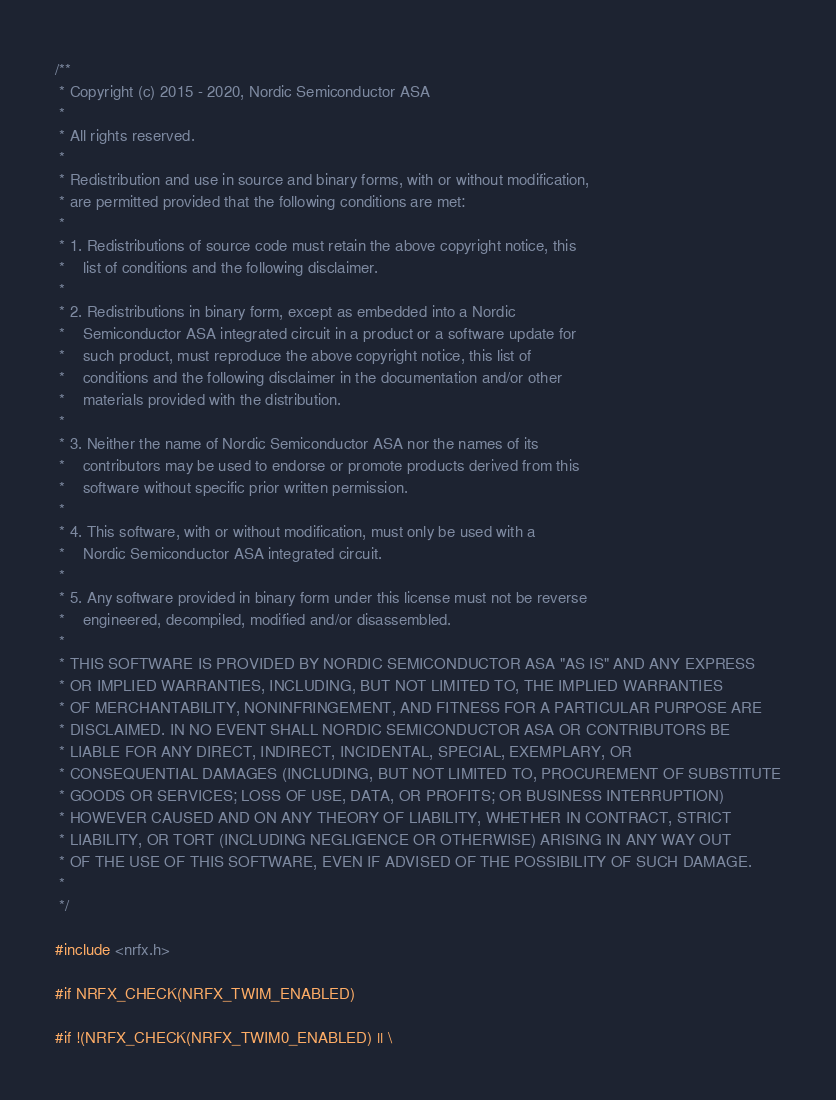<code> <loc_0><loc_0><loc_500><loc_500><_C_>/**
 * Copyright (c) 2015 - 2020, Nordic Semiconductor ASA
 *
 * All rights reserved.
 *
 * Redistribution and use in source and binary forms, with or without modification,
 * are permitted provided that the following conditions are met:
 *
 * 1. Redistributions of source code must retain the above copyright notice, this
 *    list of conditions and the following disclaimer.
 *
 * 2. Redistributions in binary form, except as embedded into a Nordic
 *    Semiconductor ASA integrated circuit in a product or a software update for
 *    such product, must reproduce the above copyright notice, this list of
 *    conditions and the following disclaimer in the documentation and/or other
 *    materials provided with the distribution.
 *
 * 3. Neither the name of Nordic Semiconductor ASA nor the names of its
 *    contributors may be used to endorse or promote products derived from this
 *    software without specific prior written permission.
 *
 * 4. This software, with or without modification, must only be used with a
 *    Nordic Semiconductor ASA integrated circuit.
 *
 * 5. Any software provided in binary form under this license must not be reverse
 *    engineered, decompiled, modified and/or disassembled.
 *
 * THIS SOFTWARE IS PROVIDED BY NORDIC SEMICONDUCTOR ASA "AS IS" AND ANY EXPRESS
 * OR IMPLIED WARRANTIES, INCLUDING, BUT NOT LIMITED TO, THE IMPLIED WARRANTIES
 * OF MERCHANTABILITY, NONINFRINGEMENT, AND FITNESS FOR A PARTICULAR PURPOSE ARE
 * DISCLAIMED. IN NO EVENT SHALL NORDIC SEMICONDUCTOR ASA OR CONTRIBUTORS BE
 * LIABLE FOR ANY DIRECT, INDIRECT, INCIDENTAL, SPECIAL, EXEMPLARY, OR
 * CONSEQUENTIAL DAMAGES (INCLUDING, BUT NOT LIMITED TO, PROCUREMENT OF SUBSTITUTE
 * GOODS OR SERVICES; LOSS OF USE, DATA, OR PROFITS; OR BUSINESS INTERRUPTION)
 * HOWEVER CAUSED AND ON ANY THEORY OF LIABILITY, WHETHER IN CONTRACT, STRICT
 * LIABILITY, OR TORT (INCLUDING NEGLIGENCE OR OTHERWISE) ARISING IN ANY WAY OUT
 * OF THE USE OF THIS SOFTWARE, EVEN IF ADVISED OF THE POSSIBILITY OF SUCH DAMAGE.
 *
 */

#include <nrfx.h>

#if NRFX_CHECK(NRFX_TWIM_ENABLED)

#if !(NRFX_CHECK(NRFX_TWIM0_ENABLED) || \</code> 